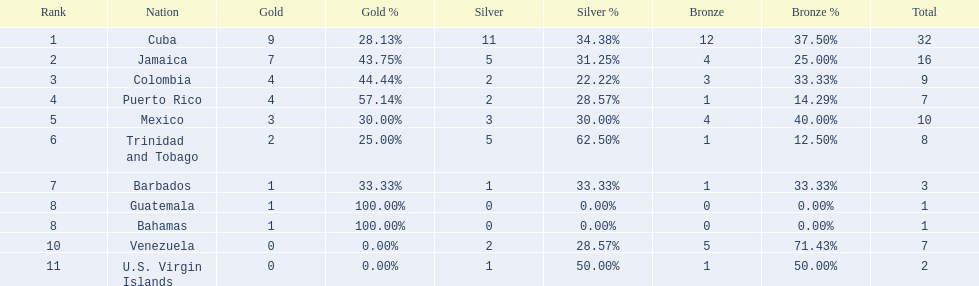The nation before mexico in the table Puerto Rico. 